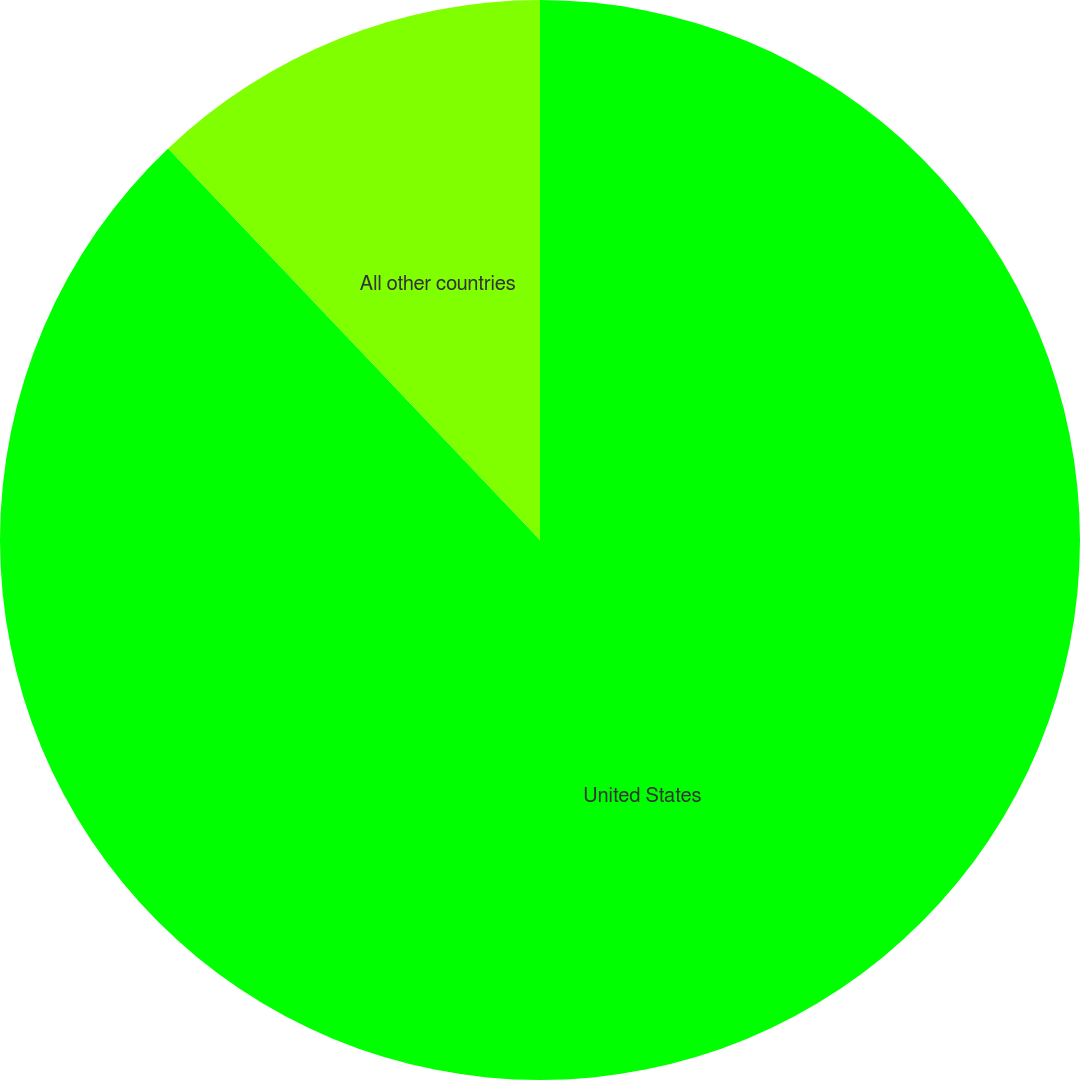<chart> <loc_0><loc_0><loc_500><loc_500><pie_chart><fcel>United States<fcel>All other countries<nl><fcel>87.91%<fcel>12.09%<nl></chart> 